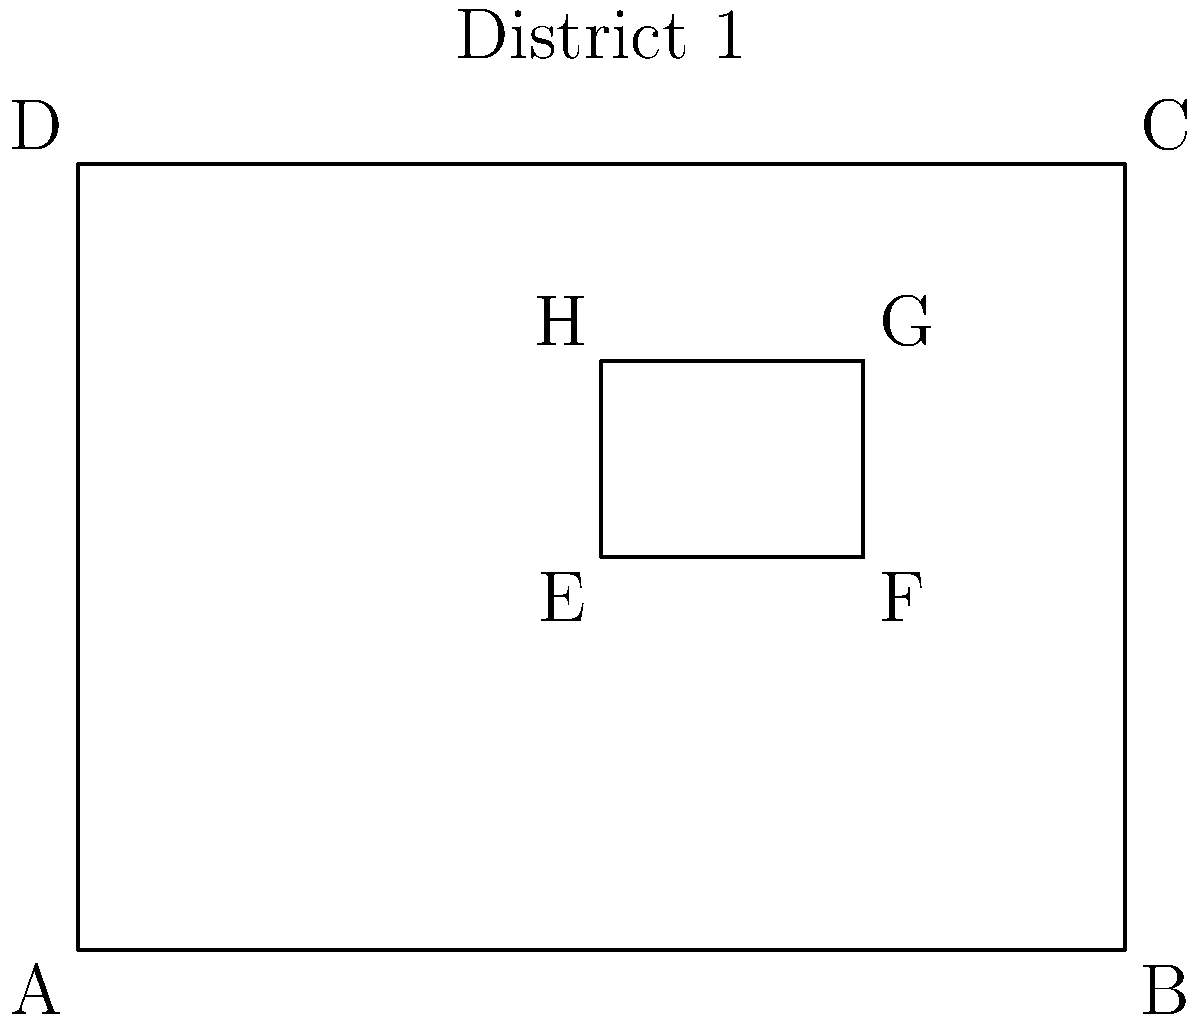In the map of Colorado's 1st House district shown above, rectangle ABCD represents the entire district, while rectangle EFGH represents a specific neighborhood. If the ratio of the area of EFGH to the area of ABCD is 1:8, what is the ratio of the perimeter of EFGH to the perimeter of ABCD? Let's approach this step-by-step:

1) First, we need to understand the relationship between the areas. If the ratio of areas is 1:8, then:
   Area of EFGH : Area of ABCD = 1 : 8

2) In similar rectangles, the ratio of areas is equal to the square of the ratio of corresponding sides. Let's call this ratio $r$. Then:
   $r^2 = 1/8$

3) Solving for $r$:
   $r = \sqrt{1/8} = 1/\sqrt{8} = 1/(2\sqrt{2})$

4) Now, this ratio $r$ applies to all corresponding linear dimensions of the rectangles, including their sides.

5) The perimeter of a rectangle is the sum of all its sides. If we denote the length and width of ABCD as $L$ and $W$ respectively, then:
   Perimeter of ABCD = $2L + 2W$
   Perimeter of EFGH = $2rL + 2rW = r(2L + 2W)$

6) Therefore, the ratio of perimeters is:
   Perimeter of EFGH : Perimeter of ABCD = $r : 1 = 1 : (2\sqrt{2})$

Thus, the ratio of the perimeter of EFGH to the perimeter of ABCD is $1 : (2\sqrt{2})$.
Answer: $1 : (2\sqrt{2})$ 